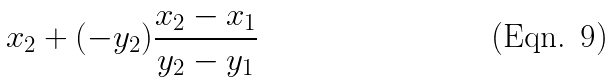<formula> <loc_0><loc_0><loc_500><loc_500>x _ { 2 } + ( - y _ { 2 } ) \frac { x _ { 2 } - x _ { 1 } } { y _ { 2 } - y _ { 1 } }</formula> 